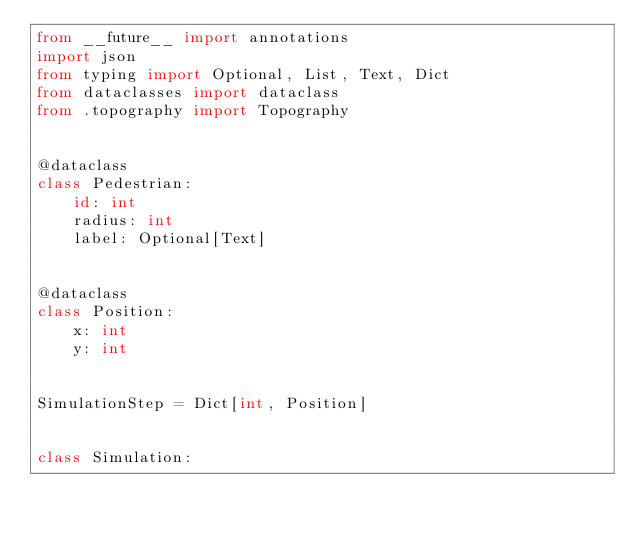Convert code to text. <code><loc_0><loc_0><loc_500><loc_500><_Python_>from __future__ import annotations
import json
from typing import Optional, List, Text, Dict
from dataclasses import dataclass
from .topography import Topography


@dataclass
class Pedestrian:
    id: int
    radius: int
    label: Optional[Text]


@dataclass
class Position:
    x: int
    y: int


SimulationStep = Dict[int, Position]


class Simulation:</code> 